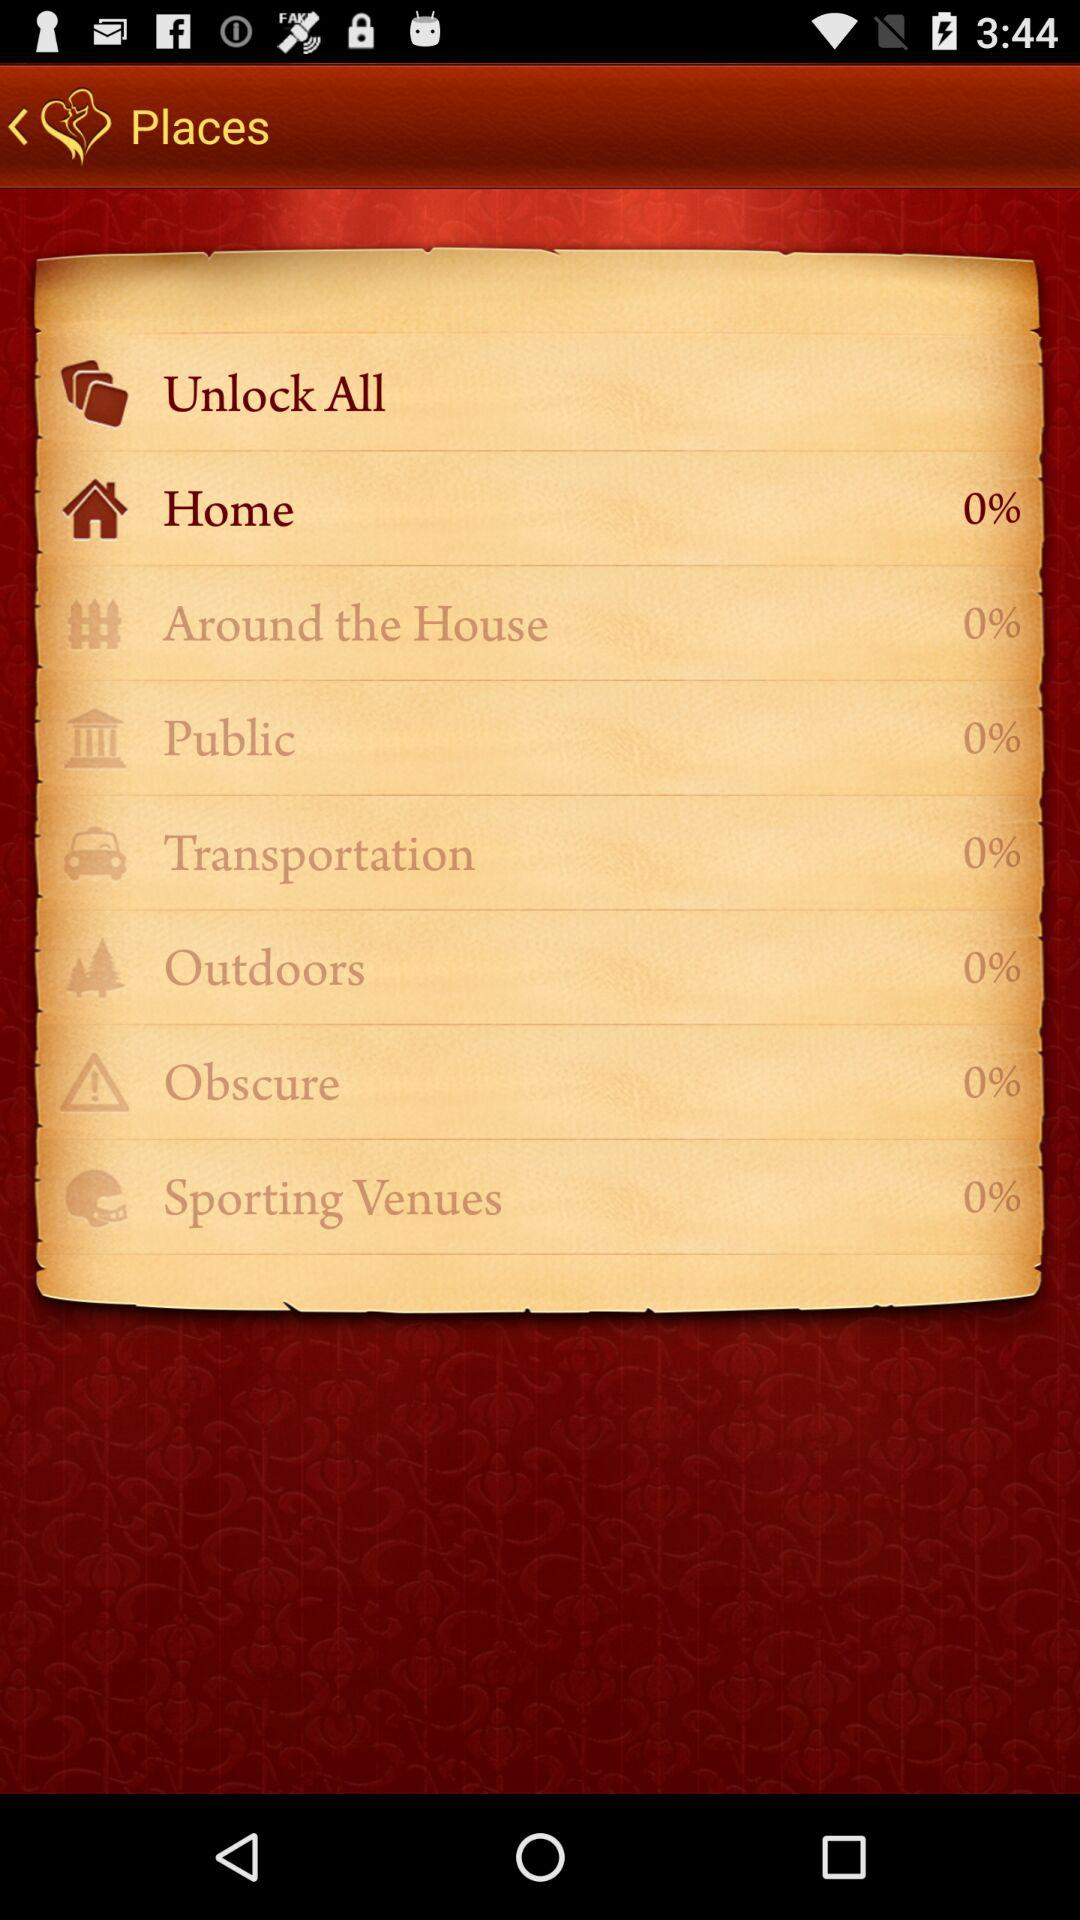What is the percentage count of the "Public"? The percentage count is 0. 